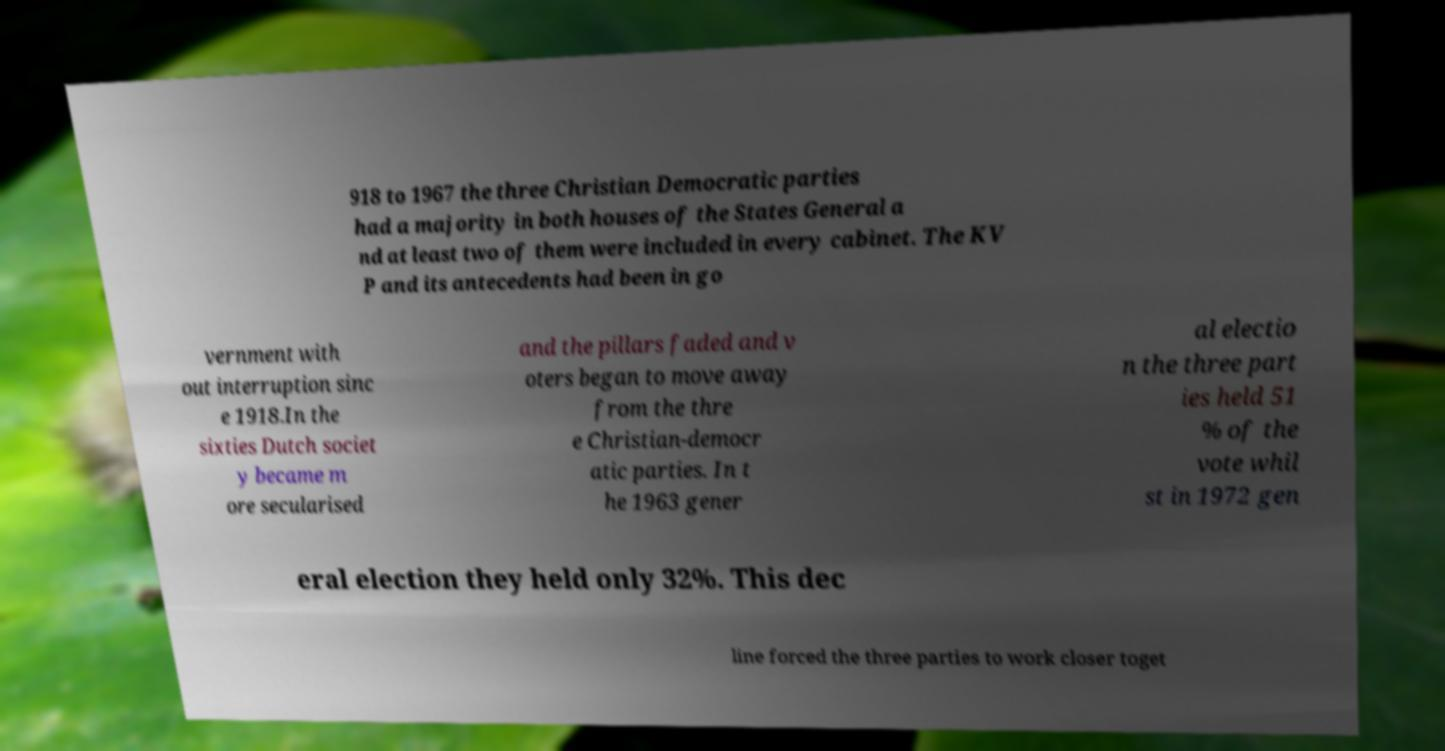Please identify and transcribe the text found in this image. 918 to 1967 the three Christian Democratic parties had a majority in both houses of the States General a nd at least two of them were included in every cabinet. The KV P and its antecedents had been in go vernment with out interruption sinc e 1918.In the sixties Dutch societ y became m ore secularised and the pillars faded and v oters began to move away from the thre e Christian-democr atic parties. In t he 1963 gener al electio n the three part ies held 51 % of the vote whil st in 1972 gen eral election they held only 32%. This dec line forced the three parties to work closer toget 